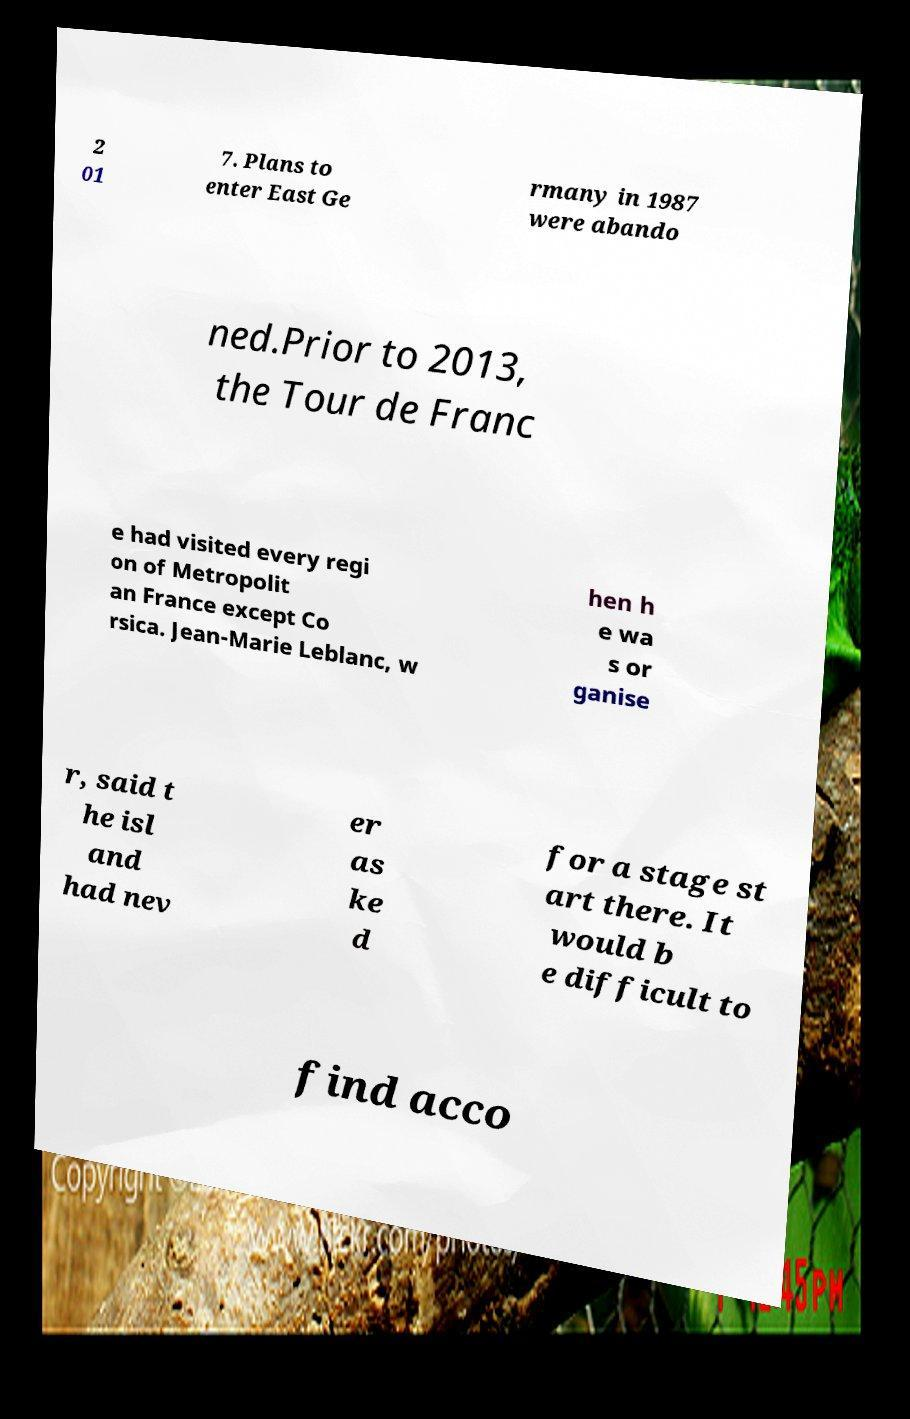Please read and relay the text visible in this image. What does it say? 2 01 7. Plans to enter East Ge rmany in 1987 were abando ned.Prior to 2013, the Tour de Franc e had visited every regi on of Metropolit an France except Co rsica. Jean-Marie Leblanc, w hen h e wa s or ganise r, said t he isl and had nev er as ke d for a stage st art there. It would b e difficult to find acco 